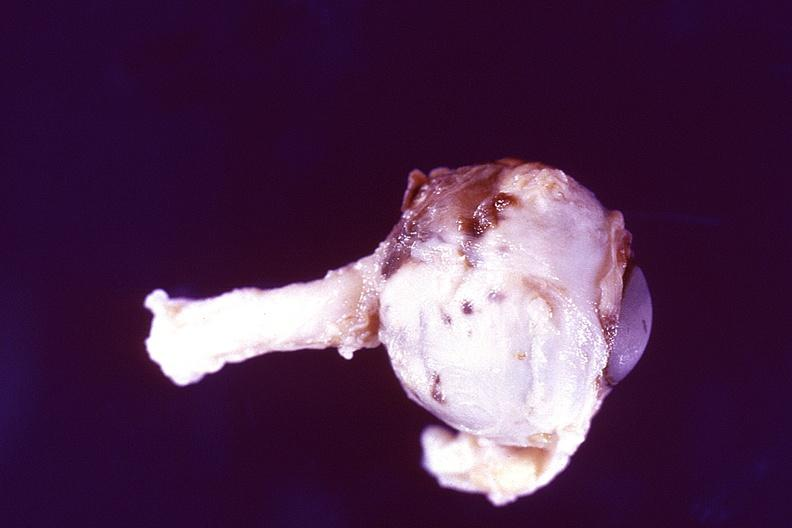what is present?
Answer the question using a single word or phrase. Eye 